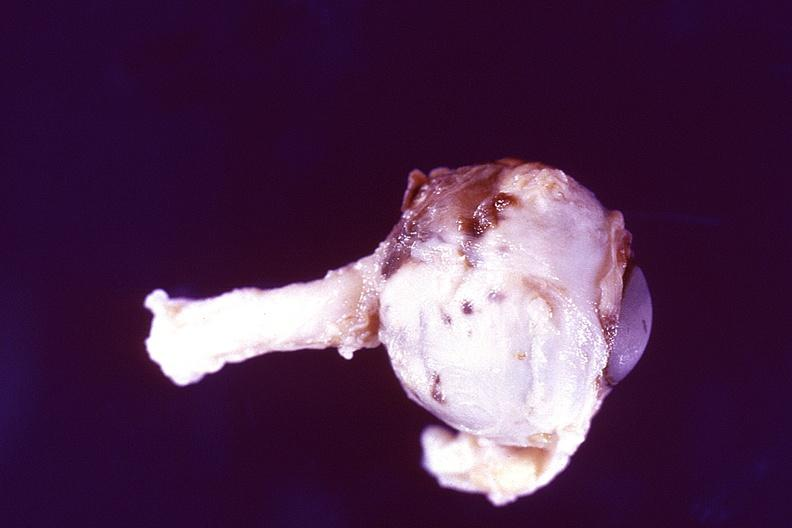what is present?
Answer the question using a single word or phrase. Eye 